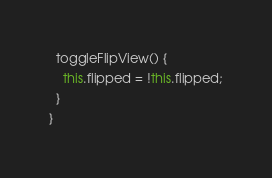<code> <loc_0><loc_0><loc_500><loc_500><_TypeScript_>
  toggleFlipView() {
    this.flipped = !this.flipped;
  }
}
</code> 